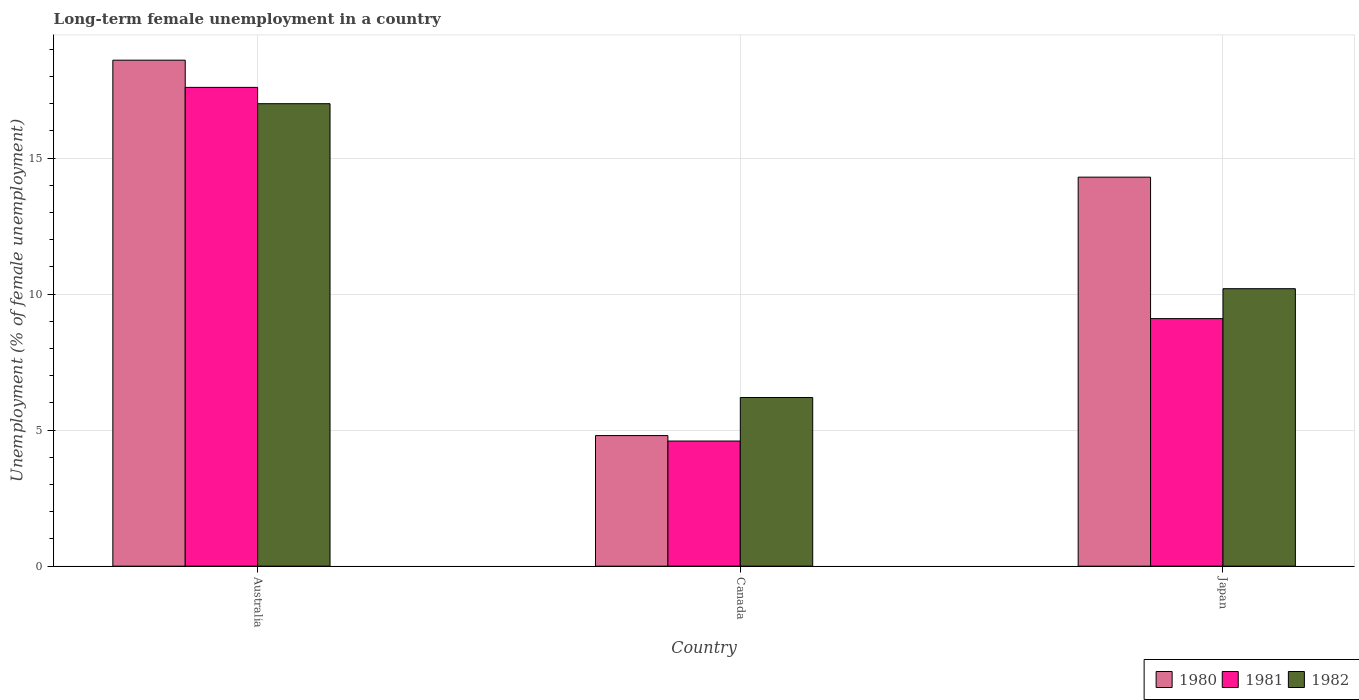How many different coloured bars are there?
Offer a very short reply. 3. How many groups of bars are there?
Your response must be concise. 3. Are the number of bars per tick equal to the number of legend labels?
Your answer should be very brief. Yes. Are the number of bars on each tick of the X-axis equal?
Provide a succinct answer. Yes. How many bars are there on the 3rd tick from the left?
Make the answer very short. 3. What is the percentage of long-term unemployed female population in 1981 in Australia?
Offer a very short reply. 17.6. Across all countries, what is the minimum percentage of long-term unemployed female population in 1980?
Your answer should be compact. 4.8. What is the total percentage of long-term unemployed female population in 1981 in the graph?
Give a very brief answer. 31.3. What is the difference between the percentage of long-term unemployed female population in 1982 in Canada and that in Japan?
Keep it short and to the point. -4. What is the difference between the percentage of long-term unemployed female population in 1980 in Australia and the percentage of long-term unemployed female population in 1981 in Japan?
Offer a terse response. 9.5. What is the average percentage of long-term unemployed female population in 1980 per country?
Offer a very short reply. 12.57. What is the difference between the percentage of long-term unemployed female population of/in 1980 and percentage of long-term unemployed female population of/in 1981 in Japan?
Your response must be concise. 5.2. In how many countries, is the percentage of long-term unemployed female population in 1980 greater than 6 %?
Ensure brevity in your answer.  2. What is the ratio of the percentage of long-term unemployed female population in 1982 in Australia to that in Canada?
Offer a very short reply. 2.74. Is the percentage of long-term unemployed female population in 1982 in Australia less than that in Canada?
Keep it short and to the point. No. What is the difference between the highest and the second highest percentage of long-term unemployed female population in 1980?
Your answer should be compact. 13.8. What is the difference between the highest and the lowest percentage of long-term unemployed female population in 1981?
Your answer should be compact. 13. In how many countries, is the percentage of long-term unemployed female population in 1981 greater than the average percentage of long-term unemployed female population in 1981 taken over all countries?
Make the answer very short. 1. Is the sum of the percentage of long-term unemployed female population in 1982 in Canada and Japan greater than the maximum percentage of long-term unemployed female population in 1980 across all countries?
Your answer should be compact. No. What does the 2nd bar from the right in Japan represents?
Your answer should be very brief. 1981. How many countries are there in the graph?
Make the answer very short. 3. What is the difference between two consecutive major ticks on the Y-axis?
Make the answer very short. 5. Does the graph contain any zero values?
Provide a succinct answer. No. Where does the legend appear in the graph?
Keep it short and to the point. Bottom right. How many legend labels are there?
Ensure brevity in your answer.  3. How are the legend labels stacked?
Provide a succinct answer. Horizontal. What is the title of the graph?
Provide a short and direct response. Long-term female unemployment in a country. Does "1978" appear as one of the legend labels in the graph?
Give a very brief answer. No. What is the label or title of the Y-axis?
Provide a short and direct response. Unemployment (% of female unemployment). What is the Unemployment (% of female unemployment) in 1980 in Australia?
Keep it short and to the point. 18.6. What is the Unemployment (% of female unemployment) in 1981 in Australia?
Provide a short and direct response. 17.6. What is the Unemployment (% of female unemployment) in 1980 in Canada?
Give a very brief answer. 4.8. What is the Unemployment (% of female unemployment) in 1981 in Canada?
Ensure brevity in your answer.  4.6. What is the Unemployment (% of female unemployment) in 1982 in Canada?
Your answer should be very brief. 6.2. What is the Unemployment (% of female unemployment) of 1980 in Japan?
Ensure brevity in your answer.  14.3. What is the Unemployment (% of female unemployment) of 1981 in Japan?
Provide a succinct answer. 9.1. What is the Unemployment (% of female unemployment) of 1982 in Japan?
Give a very brief answer. 10.2. Across all countries, what is the maximum Unemployment (% of female unemployment) in 1980?
Provide a succinct answer. 18.6. Across all countries, what is the maximum Unemployment (% of female unemployment) in 1981?
Offer a very short reply. 17.6. Across all countries, what is the maximum Unemployment (% of female unemployment) of 1982?
Provide a succinct answer. 17. Across all countries, what is the minimum Unemployment (% of female unemployment) of 1980?
Ensure brevity in your answer.  4.8. Across all countries, what is the minimum Unemployment (% of female unemployment) in 1981?
Keep it short and to the point. 4.6. Across all countries, what is the minimum Unemployment (% of female unemployment) of 1982?
Offer a terse response. 6.2. What is the total Unemployment (% of female unemployment) in 1980 in the graph?
Keep it short and to the point. 37.7. What is the total Unemployment (% of female unemployment) of 1981 in the graph?
Offer a very short reply. 31.3. What is the total Unemployment (% of female unemployment) of 1982 in the graph?
Offer a terse response. 33.4. What is the difference between the Unemployment (% of female unemployment) in 1982 in Australia and that in Canada?
Your response must be concise. 10.8. What is the difference between the Unemployment (% of female unemployment) of 1980 in Australia and that in Japan?
Provide a succinct answer. 4.3. What is the difference between the Unemployment (% of female unemployment) in 1981 in Australia and that in Japan?
Your answer should be compact. 8.5. What is the difference between the Unemployment (% of female unemployment) in 1982 in Australia and that in Japan?
Your answer should be very brief. 6.8. What is the difference between the Unemployment (% of female unemployment) of 1980 in Canada and that in Japan?
Offer a terse response. -9.5. What is the difference between the Unemployment (% of female unemployment) of 1981 in Canada and that in Japan?
Your answer should be compact. -4.5. What is the difference between the Unemployment (% of female unemployment) in 1980 in Australia and the Unemployment (% of female unemployment) in 1982 in Canada?
Provide a short and direct response. 12.4. What is the difference between the Unemployment (% of female unemployment) in 1980 in Australia and the Unemployment (% of female unemployment) in 1982 in Japan?
Your answer should be compact. 8.4. What is the difference between the Unemployment (% of female unemployment) of 1980 in Canada and the Unemployment (% of female unemployment) of 1982 in Japan?
Give a very brief answer. -5.4. What is the difference between the Unemployment (% of female unemployment) of 1981 in Canada and the Unemployment (% of female unemployment) of 1982 in Japan?
Your response must be concise. -5.6. What is the average Unemployment (% of female unemployment) in 1980 per country?
Provide a succinct answer. 12.57. What is the average Unemployment (% of female unemployment) of 1981 per country?
Offer a terse response. 10.43. What is the average Unemployment (% of female unemployment) of 1982 per country?
Ensure brevity in your answer.  11.13. What is the difference between the Unemployment (% of female unemployment) in 1980 and Unemployment (% of female unemployment) in 1982 in Australia?
Provide a succinct answer. 1.6. What is the difference between the Unemployment (% of female unemployment) in 1981 and Unemployment (% of female unemployment) in 1982 in Australia?
Offer a terse response. 0.6. What is the difference between the Unemployment (% of female unemployment) in 1980 and Unemployment (% of female unemployment) in 1981 in Canada?
Make the answer very short. 0.2. What is the difference between the Unemployment (% of female unemployment) of 1980 and Unemployment (% of female unemployment) of 1982 in Canada?
Offer a very short reply. -1.4. What is the difference between the Unemployment (% of female unemployment) of 1980 and Unemployment (% of female unemployment) of 1981 in Japan?
Keep it short and to the point. 5.2. What is the difference between the Unemployment (% of female unemployment) in 1980 and Unemployment (% of female unemployment) in 1982 in Japan?
Keep it short and to the point. 4.1. What is the ratio of the Unemployment (% of female unemployment) in 1980 in Australia to that in Canada?
Your response must be concise. 3.88. What is the ratio of the Unemployment (% of female unemployment) in 1981 in Australia to that in Canada?
Your answer should be compact. 3.83. What is the ratio of the Unemployment (% of female unemployment) of 1982 in Australia to that in Canada?
Offer a very short reply. 2.74. What is the ratio of the Unemployment (% of female unemployment) of 1980 in Australia to that in Japan?
Provide a succinct answer. 1.3. What is the ratio of the Unemployment (% of female unemployment) of 1981 in Australia to that in Japan?
Your response must be concise. 1.93. What is the ratio of the Unemployment (% of female unemployment) of 1980 in Canada to that in Japan?
Your answer should be compact. 0.34. What is the ratio of the Unemployment (% of female unemployment) of 1981 in Canada to that in Japan?
Make the answer very short. 0.51. What is the ratio of the Unemployment (% of female unemployment) in 1982 in Canada to that in Japan?
Make the answer very short. 0.61. What is the difference between the highest and the second highest Unemployment (% of female unemployment) of 1982?
Offer a terse response. 6.8. What is the difference between the highest and the lowest Unemployment (% of female unemployment) in 1980?
Provide a short and direct response. 13.8. What is the difference between the highest and the lowest Unemployment (% of female unemployment) in 1981?
Your response must be concise. 13. What is the difference between the highest and the lowest Unemployment (% of female unemployment) of 1982?
Your answer should be very brief. 10.8. 